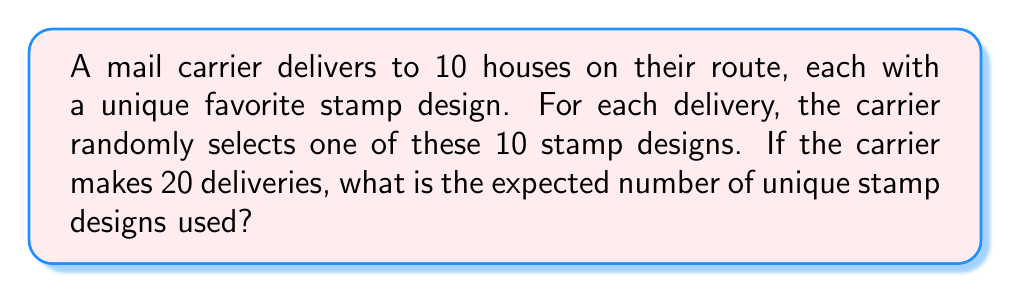Can you solve this math problem? Let's approach this step-by-step using the concept of linearity of expectation:

1) Let $X_i$ be a random variable for each stamp design $i$ (where $i = 1, 2, ..., 10$), such that:
   $X_i = \begin{cases} 1 & \text{if stamp design i is used at least once} \\ 0 & \text{otherwise} \end{cases}$

2) The probability of not using stamp design $i$ in a single delivery is $\frac{9}{10}$.

3) The probability of not using stamp design $i$ in all 20 deliveries is $(\frac{9}{10})^{20}$.

4) Therefore, the probability of using stamp design $i$ at least once is:
   $P(X_i = 1) = 1 - (\frac{9}{10})^{20}$

5) The expected value of $X_i$ is:
   $E(X_i) = 1 \cdot P(X_i = 1) + 0 \cdot P(X_i = 0) = 1 - (\frac{9}{10})^{20}$

6) Let $Y$ be the total number of unique stamp designs used. Then $Y = \sum_{i=1}^{10} X_i$

7) By linearity of expectation:
   $E(Y) = E(\sum_{i=1}^{10} X_i) = \sum_{i=1}^{10} E(X_i) = 10 \cdot (1 - (\frac{9}{10})^{20})$

8) Calculate the result:
   $E(Y) = 10 \cdot (1 - (\frac{9}{10})^{20}) \approx 8.7848$
Answer: $10 \cdot (1 - (\frac{9}{10})^{20}) \approx 8.7848$ 